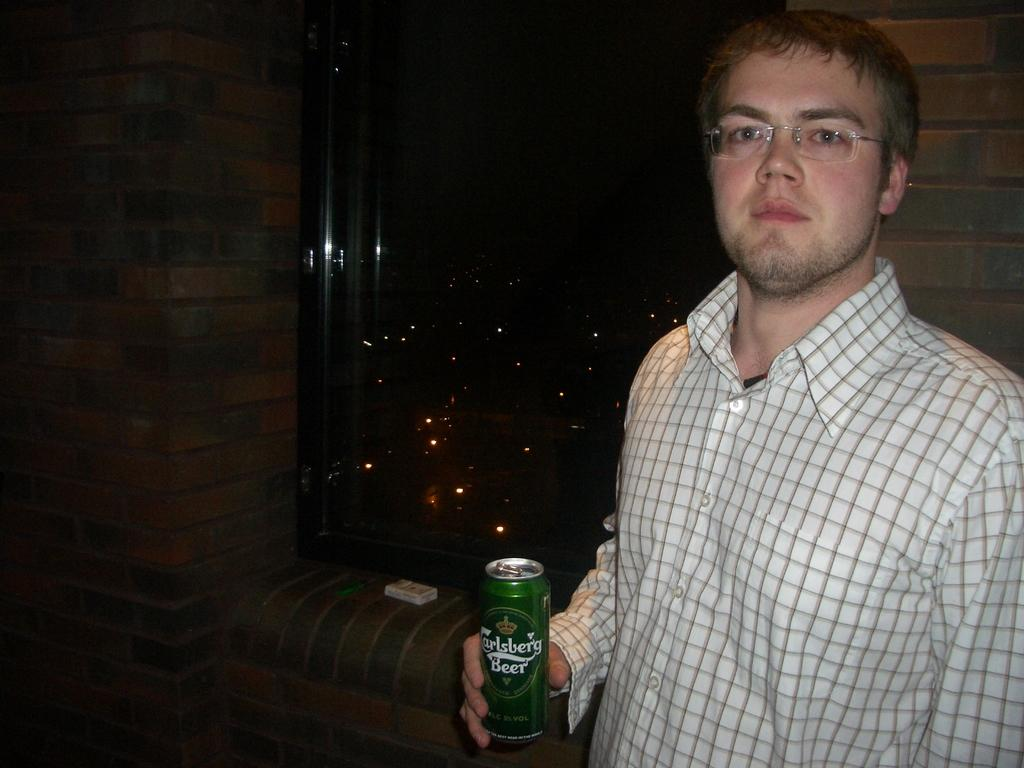Who or what is present in the image? There is a person in the image. What is the person wearing? The person is wearing a white shirt. What is the person holding in his right hand? The person is holding a beer in his right hand. What can be seen behind the person? There is a window visible behind the person. How many teeth can be seen in the person's mouth in the image? There is no visible teeth in the person's mouth in the image, so it cannot be determined. Are there any bears visible in the image? There are no bears present in the image. 